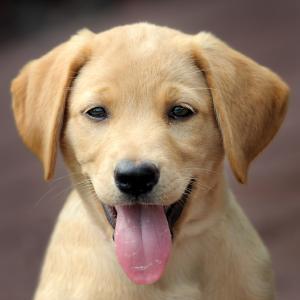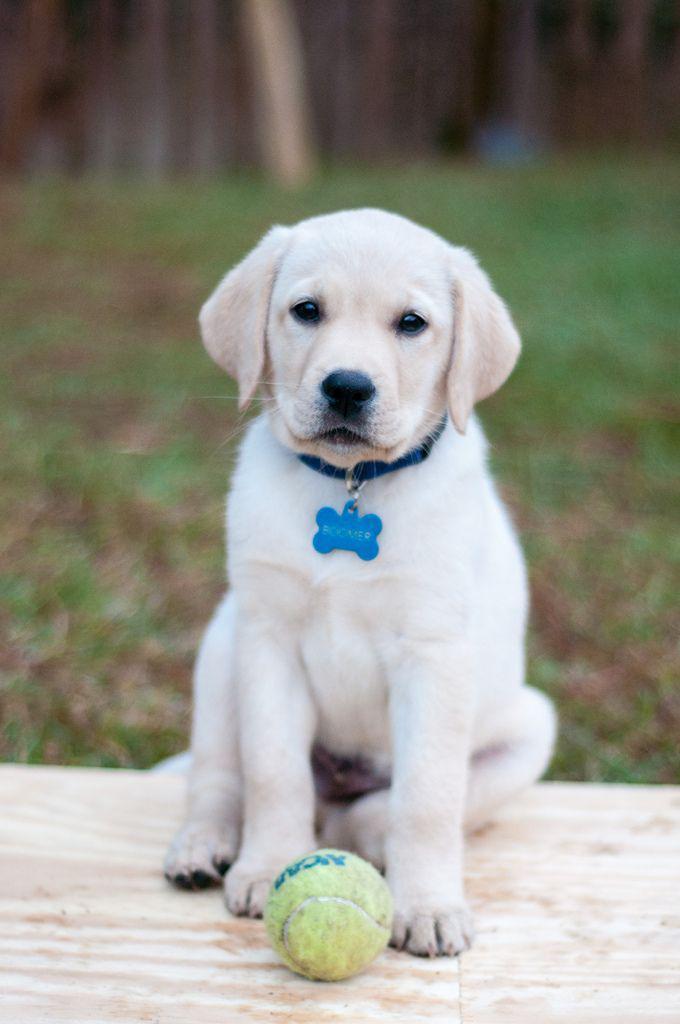The first image is the image on the left, the second image is the image on the right. Analyze the images presented: Is the assertion "Right image shows a pale puppy with some kind of play-thing." valid? Answer yes or no. Yes. The first image is the image on the left, the second image is the image on the right. Given the left and right images, does the statement "Two little dogs are shown, one with a toy." hold true? Answer yes or no. Yes. 